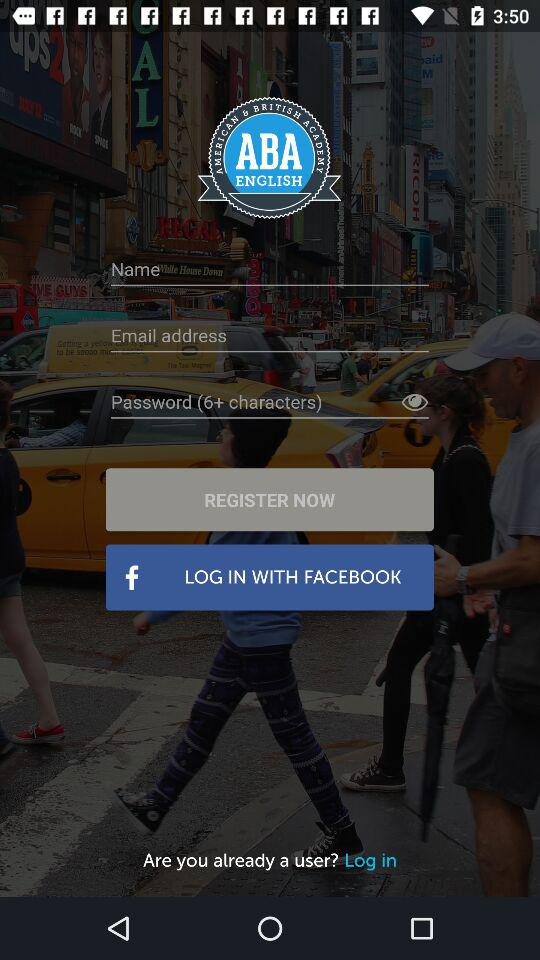What application can be used for logging in? The application that can be used for logging in is "FACEBOOK". 